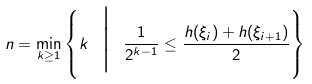<formula> <loc_0><loc_0><loc_500><loc_500>n = \min _ { k \geq 1 } \left \{ k \ \Big | \ \frac { 1 } { 2 ^ { k - 1 } } \leq \frac { h ( \xi _ { i } ) + h ( \xi _ { i + 1 } ) } { 2 } \right \}</formula> 